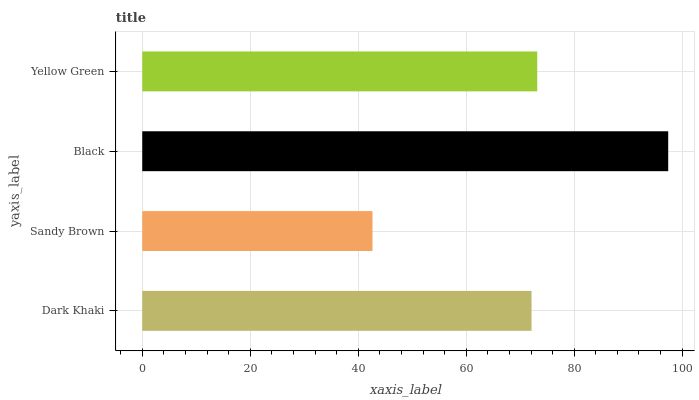Is Sandy Brown the minimum?
Answer yes or no. Yes. Is Black the maximum?
Answer yes or no. Yes. Is Black the minimum?
Answer yes or no. No. Is Sandy Brown the maximum?
Answer yes or no. No. Is Black greater than Sandy Brown?
Answer yes or no. Yes. Is Sandy Brown less than Black?
Answer yes or no. Yes. Is Sandy Brown greater than Black?
Answer yes or no. No. Is Black less than Sandy Brown?
Answer yes or no. No. Is Yellow Green the high median?
Answer yes or no. Yes. Is Dark Khaki the low median?
Answer yes or no. Yes. Is Black the high median?
Answer yes or no. No. Is Sandy Brown the low median?
Answer yes or no. No. 